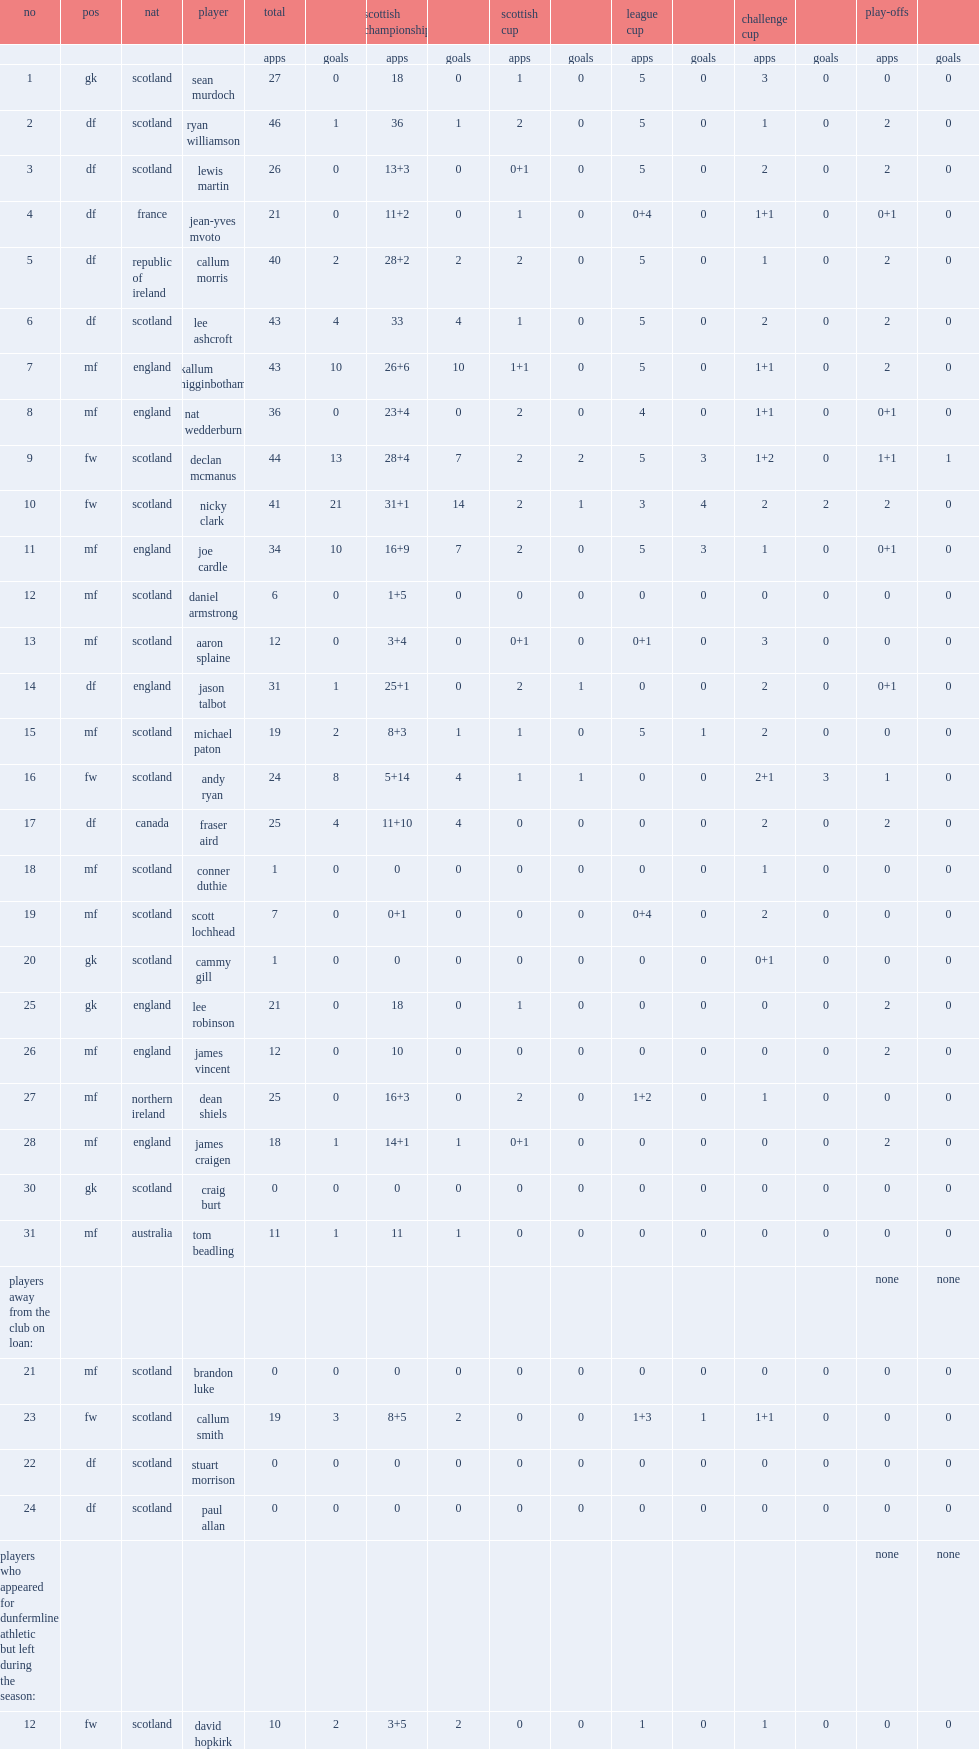List the matches that dunfermline competed in. Scottish cup league cup challenge cup. 